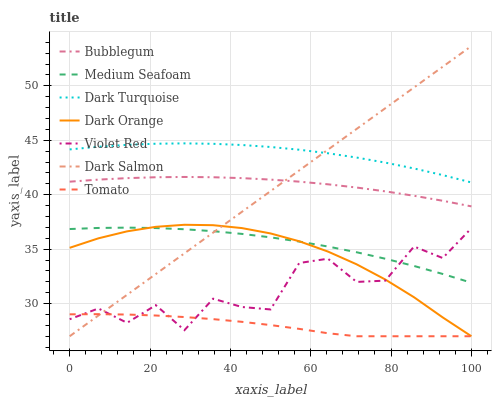Does Tomato have the minimum area under the curve?
Answer yes or no. Yes. Does Dark Turquoise have the maximum area under the curve?
Answer yes or no. Yes. Does Dark Orange have the minimum area under the curve?
Answer yes or no. No. Does Dark Orange have the maximum area under the curve?
Answer yes or no. No. Is Dark Salmon the smoothest?
Answer yes or no. Yes. Is Violet Red the roughest?
Answer yes or no. Yes. Is Dark Orange the smoothest?
Answer yes or no. No. Is Dark Orange the roughest?
Answer yes or no. No. Does Tomato have the lowest value?
Answer yes or no. Yes. Does Violet Red have the lowest value?
Answer yes or no. No. Does Dark Salmon have the highest value?
Answer yes or no. Yes. Does Dark Orange have the highest value?
Answer yes or no. No. Is Medium Seafoam less than Dark Turquoise?
Answer yes or no. Yes. Is Dark Turquoise greater than Dark Orange?
Answer yes or no. Yes. Does Violet Red intersect Medium Seafoam?
Answer yes or no. Yes. Is Violet Red less than Medium Seafoam?
Answer yes or no. No. Is Violet Red greater than Medium Seafoam?
Answer yes or no. No. Does Medium Seafoam intersect Dark Turquoise?
Answer yes or no. No. 